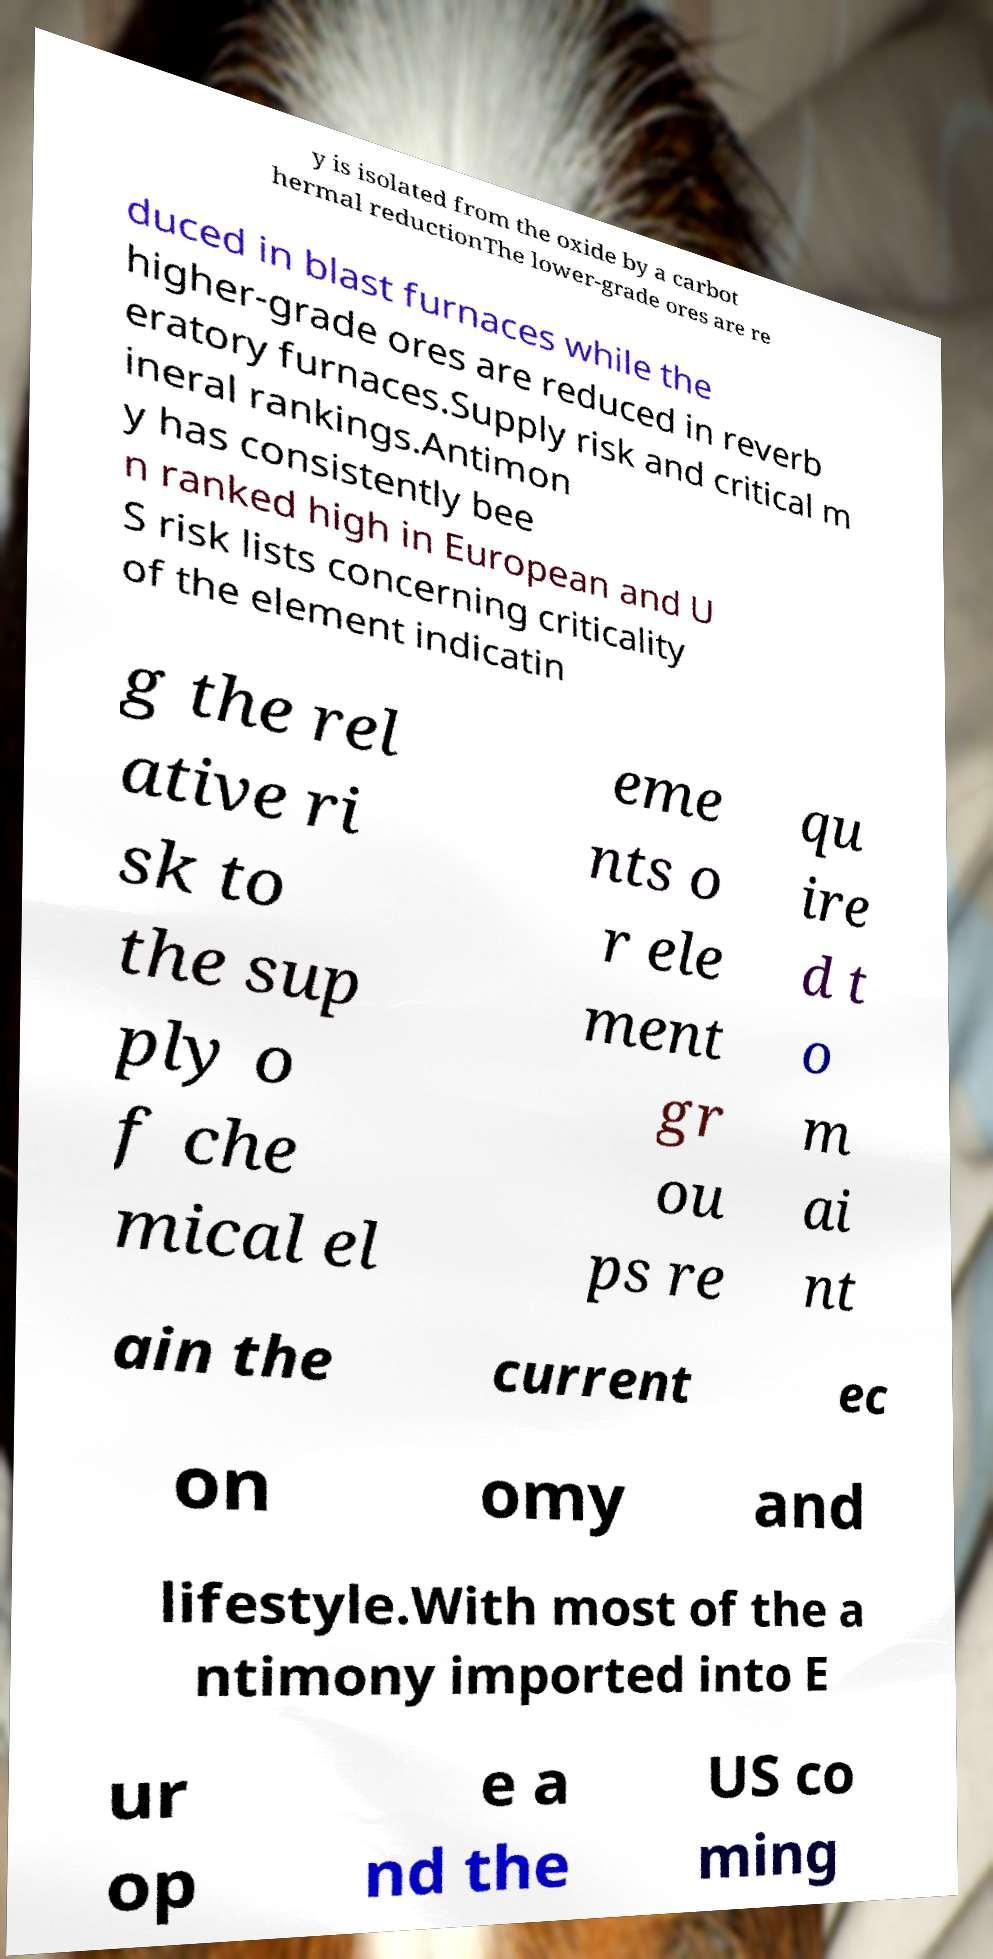I need the written content from this picture converted into text. Can you do that? y is isolated from the oxide by a carbot hermal reductionThe lower-grade ores are re duced in blast furnaces while the higher-grade ores are reduced in reverb eratory furnaces.Supply risk and critical m ineral rankings.Antimon y has consistently bee n ranked high in European and U S risk lists concerning criticality of the element indicatin g the rel ative ri sk to the sup ply o f che mical el eme nts o r ele ment gr ou ps re qu ire d t o m ai nt ain the current ec on omy and lifestyle.With most of the a ntimony imported into E ur op e a nd the US co ming 